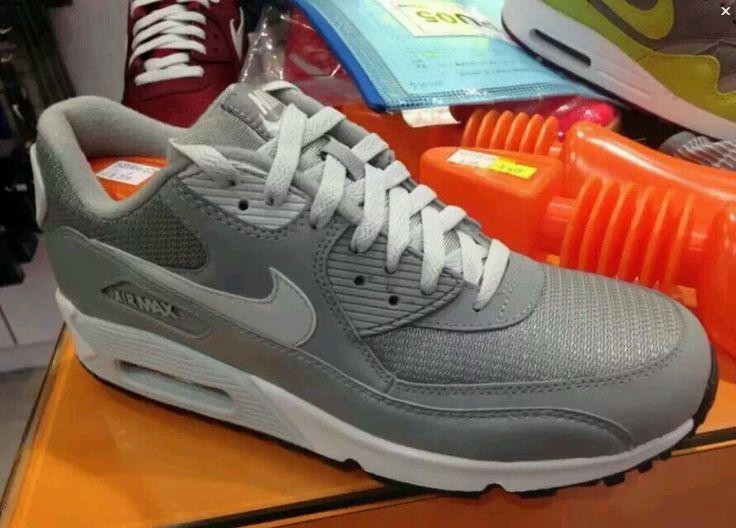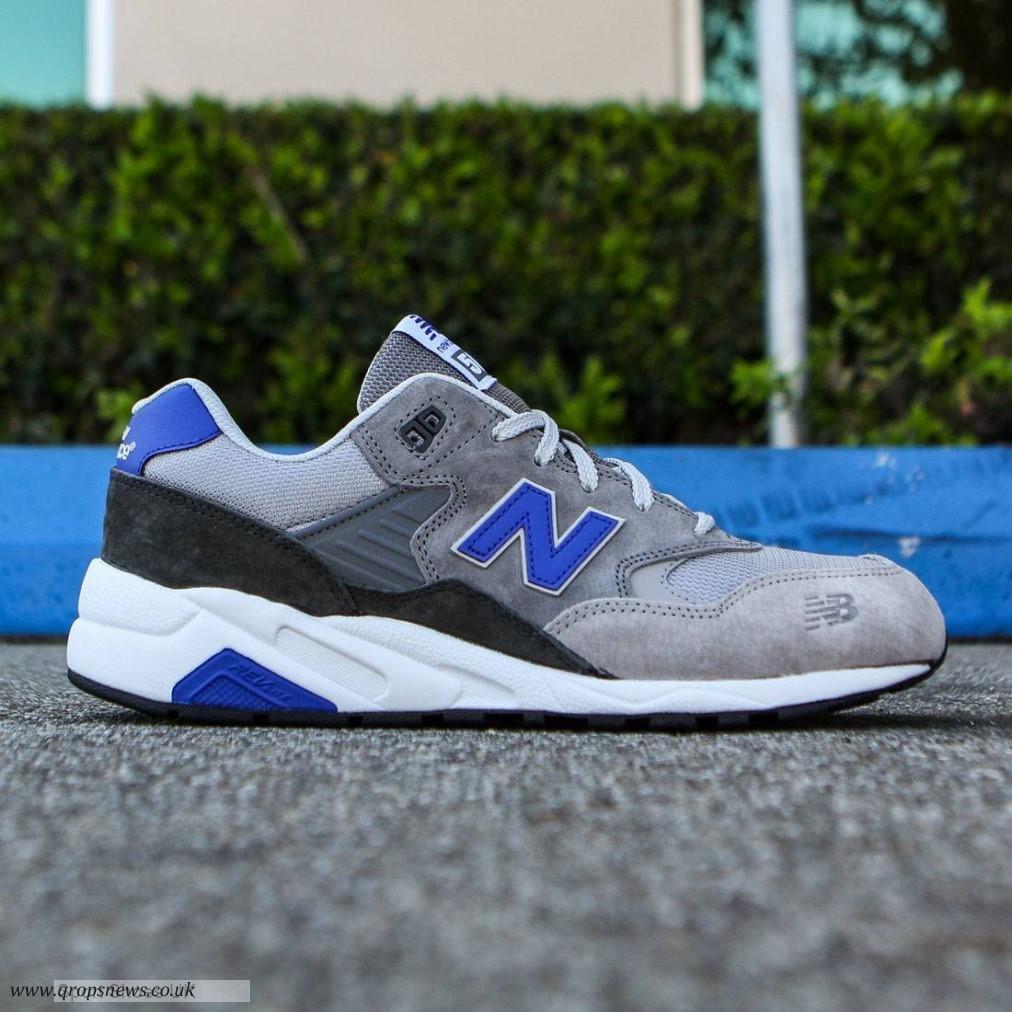The first image is the image on the left, the second image is the image on the right. Assess this claim about the two images: "An image shows a single, predominantly blue shoe in profile.". Correct or not? Answer yes or no. No. The first image is the image on the left, the second image is the image on the right. Assess this claim about the two images: "There are 2 shoes facing to the right.". Correct or not? Answer yes or no. Yes. 